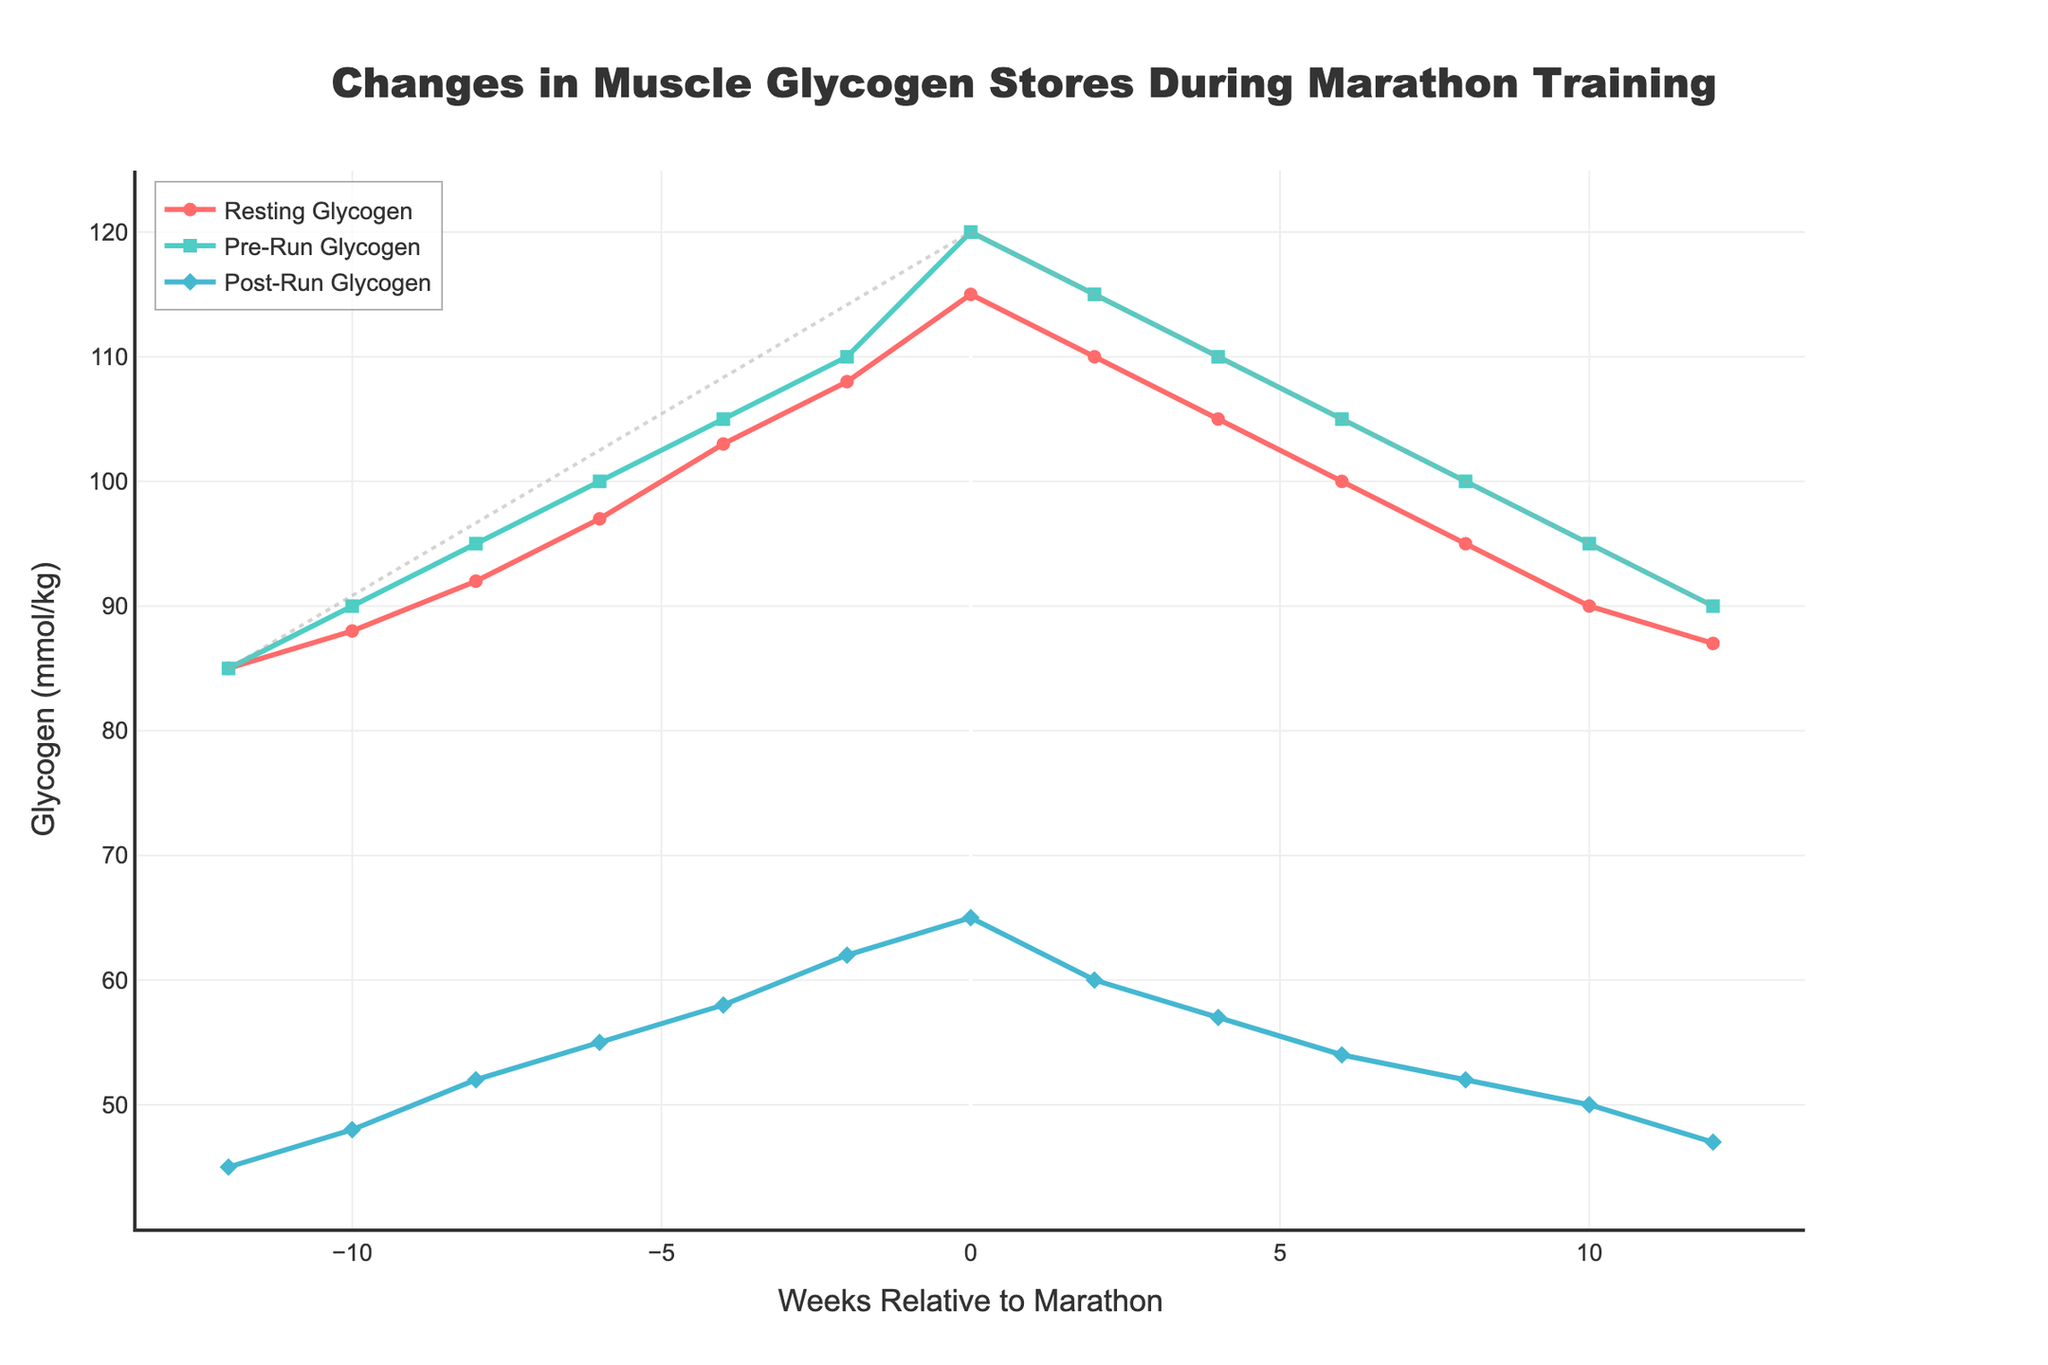What are the resting muscle glycogen levels at weeks -12 and 12? At week -12, the resting muscle glycogen level is indicated by the starting point of the red line. At week 12, the resting muscle glycogen level is indicated by the final point of the red line.
Answer: 85 and 87 mmol/kg How do the pre-run glycogen levels change from week 0 to week 12? At week 0, the pre-run glycogen level is indicated by the position of the green line. Follow the green line to week 12 to see the change.
Answer: It decreases from 120 to 90 mmol/kg What’s the difference between pre-run and post-run glycogen levels at week 0? At week 0, identify the points on the green and blue lines. Subtract the post-run value (blue) from the pre-run value (green).
Answer: 120 - 65 = 55 mmol/kg At which week is the post-run glycogen level the highest? The highest point on the blue line represents the highest post-run glycogen level. Identify the corresponding week on the x-axis.
Answer: Week 0 How do the resting glycogen levels change before and after week 0? Observe the red line before and after week 0, noting the trajectory and magnitude of changes. The line rises from week -12 to week 0 and falls from week 0 to week 12.
Answer: Increases before week 0, decreases after Compare the glycogen levels (pre-run, post-run) in week -2 and week 2. Identify the levels indicated by the green and blue lines at weeks -2 and 2. Compare the values directly.
Answer: Week -2: 110 (pre), 62 (post); Week 2: 115 (pre), 60 (post) What visual cues indicate the overall trend of the resting glycogen levels over time? The upward and then downward slope of the red line from week -12 to week 0 and week 0 to week 12, respectively, indicates this trend.
Answer: Red line slopes up, peaks at week 0, then slopes down What general relationship is observed between the pre-run and post-run glycogen levels throughout the training period? The green line (pre-run) is consistently higher than the blue line (post-run), indicating that pre-run levels are always higher than post-run levels.
Answer: Pre-run is always higher than post-run What are the average pre-run glycogen levels from week -12 to 0? Sum the pre-run glycogen levels (green line) at each point from week -12 to 0, then divide by the number of points.
Answer: (85+90+95+100+105+110+120)/7 = 100 mmol/kg How does the post-run glycogen level at week 12 compare with that at week -12? Compare the points on the blue line at weeks -12 and 12.
Answer: Week -12: 45 mmol/kg, Week 12: 47 mmol/kg. Levels are slightly higher at week 12 Explain the significance of the dashed lines in the plot. The upward and downward dashed lines represent training phase trends - increase to peak glycogen reserves by week 0, followed by depletion post-marathon.
Answer: Indicate rising and falling trends 